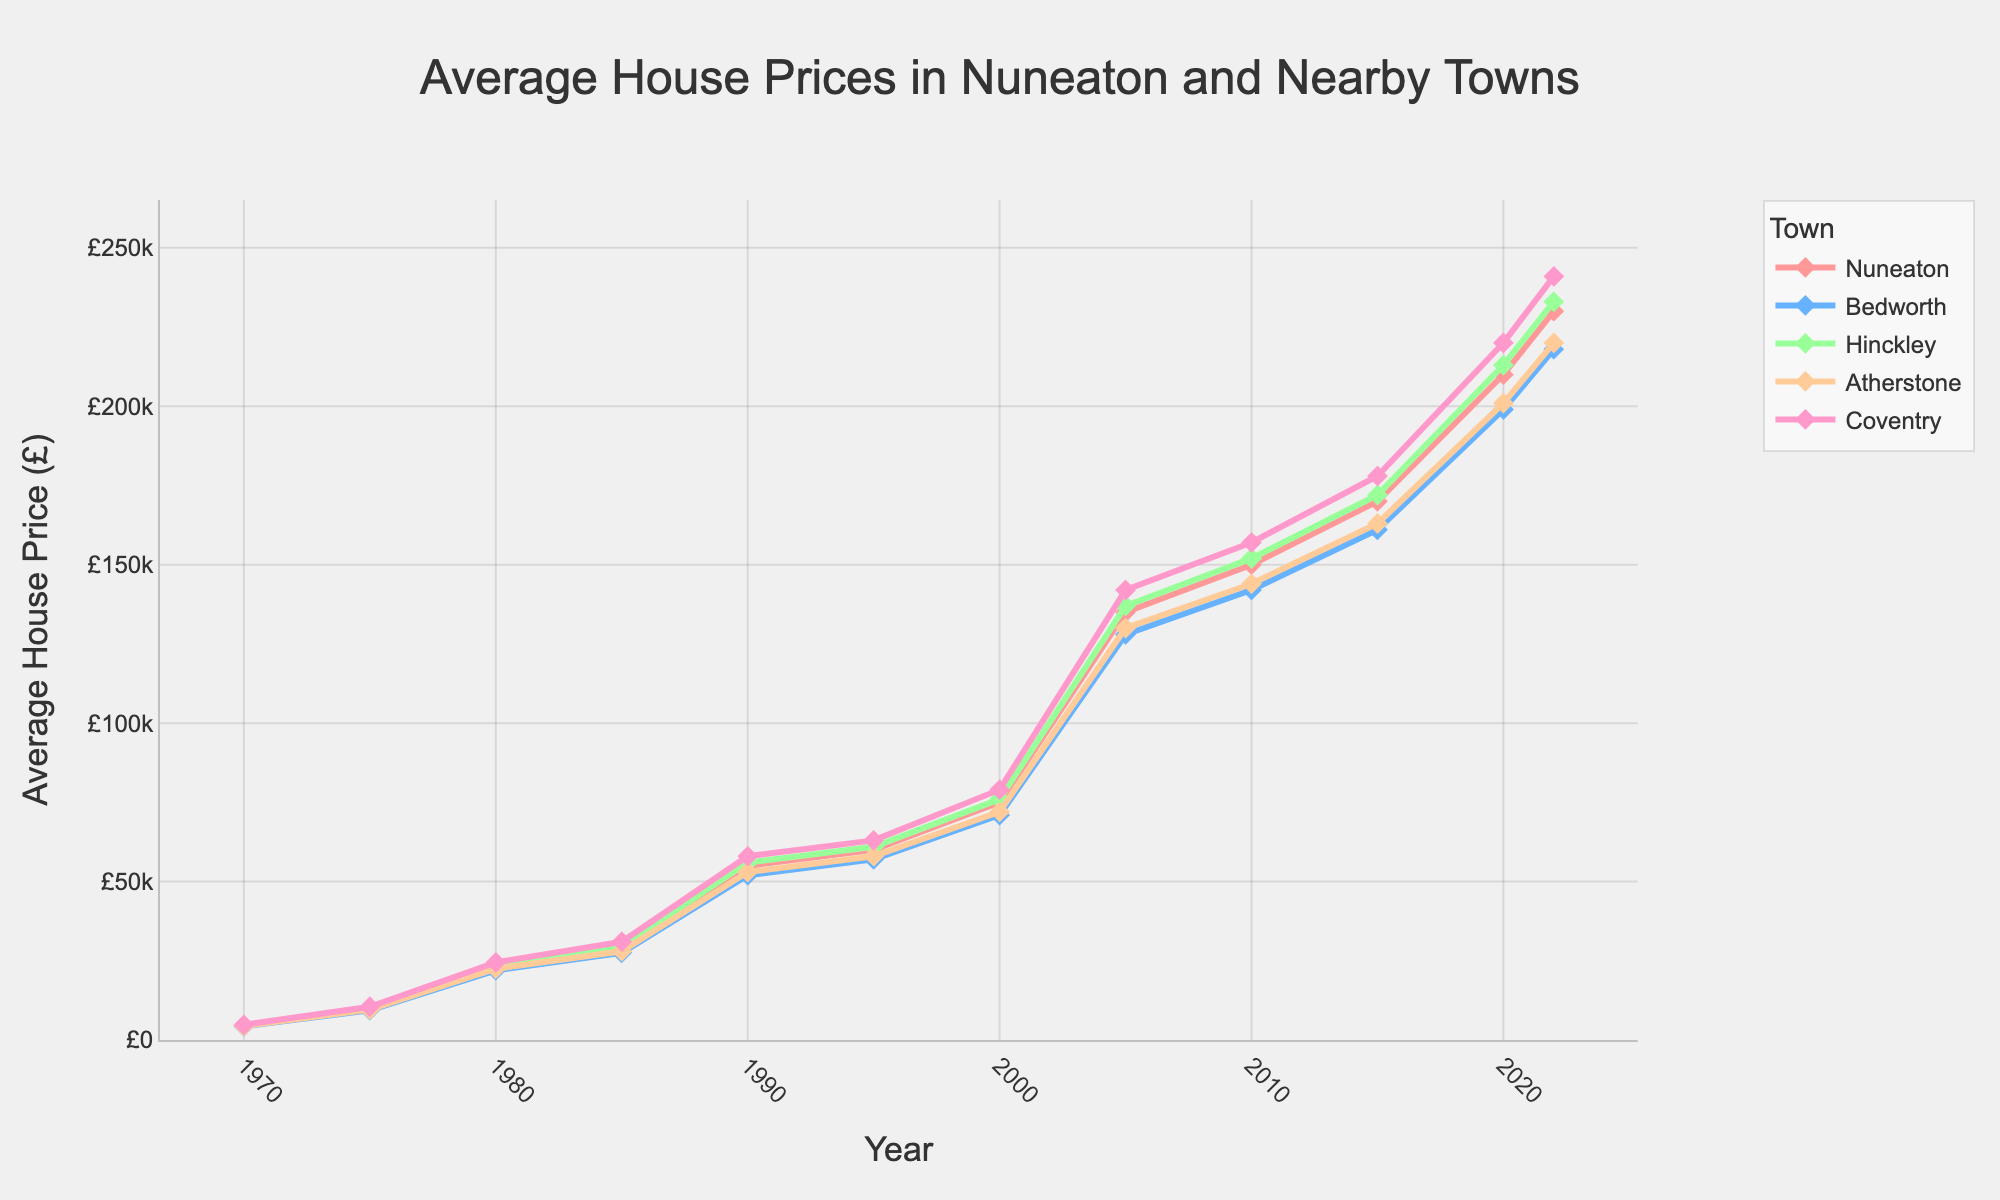What's the average house price in Nuneaton in 1980 and 2000? The house prices in Nuneaton in 1980 and 2000 are £23000 and £75000, respectively. The average is calculated as (£23000 + £75000) / 2 = £49000
Answer: £49000 How much did the house prices in Hinckley increase from 1970 to 2022? The house prices in Hinckley in 1970 was £4600 and in 2022 it was £233000. The increase is £233000 - £4600 = £228400
Answer: £228400 Which town had the highest house prices in 2015? By looking at the figure, Coventry had the highest house prices in 2015 at £178000
Answer: Coventry Compare the house prices in Nuneaton and Atherstone in 2020. Which town had lower house prices and by how much? In 2020, the house prices in Nuneaton were £210000 and in Atherstone £201000. Nuneaton had higher house prices. The difference is £210000 - £201000 = £9000. So, Atherstone had lower house prices by £9000
Answer: Atherstone, £9000 What's the overall trend of house prices in Nuneaton from 1970 to 2022? The overall trend of house prices in Nuneaton from 1970 to 2022 shows a consistent increase over time
Answer: Increasing Which town had a higher house price in 1995, Bedworth or Coventry, and by how much? In 1995, the house prices in Bedworth were £57000 and in Coventry were £63000. Coventry had higher house prices. The difference is £63000 - £57000 = £6000
Answer: Coventry, £6000 